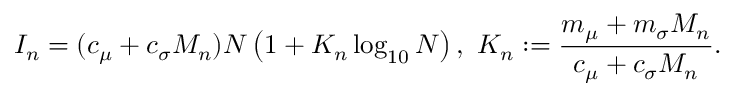Convert formula to latex. <formula><loc_0><loc_0><loc_500><loc_500>I _ { n } = ( c _ { \mu } + c _ { \sigma } M _ { n } ) N \left ( 1 + K _ { n } \log _ { 1 0 } N \right ) , \, K _ { n } \colon = \frac { m _ { \mu } + m _ { \sigma } M _ { n } } { c _ { \mu } + c _ { \sigma } M _ { n } } .</formula> 